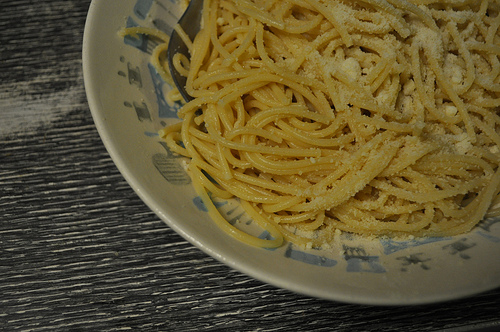<image>
Is the pasta in the bowl? Yes. The pasta is contained within or inside the bowl, showing a containment relationship. Where is the plate in relation to the spoon? Is it to the left of the spoon? No. The plate is not to the left of the spoon. From this viewpoint, they have a different horizontal relationship. 